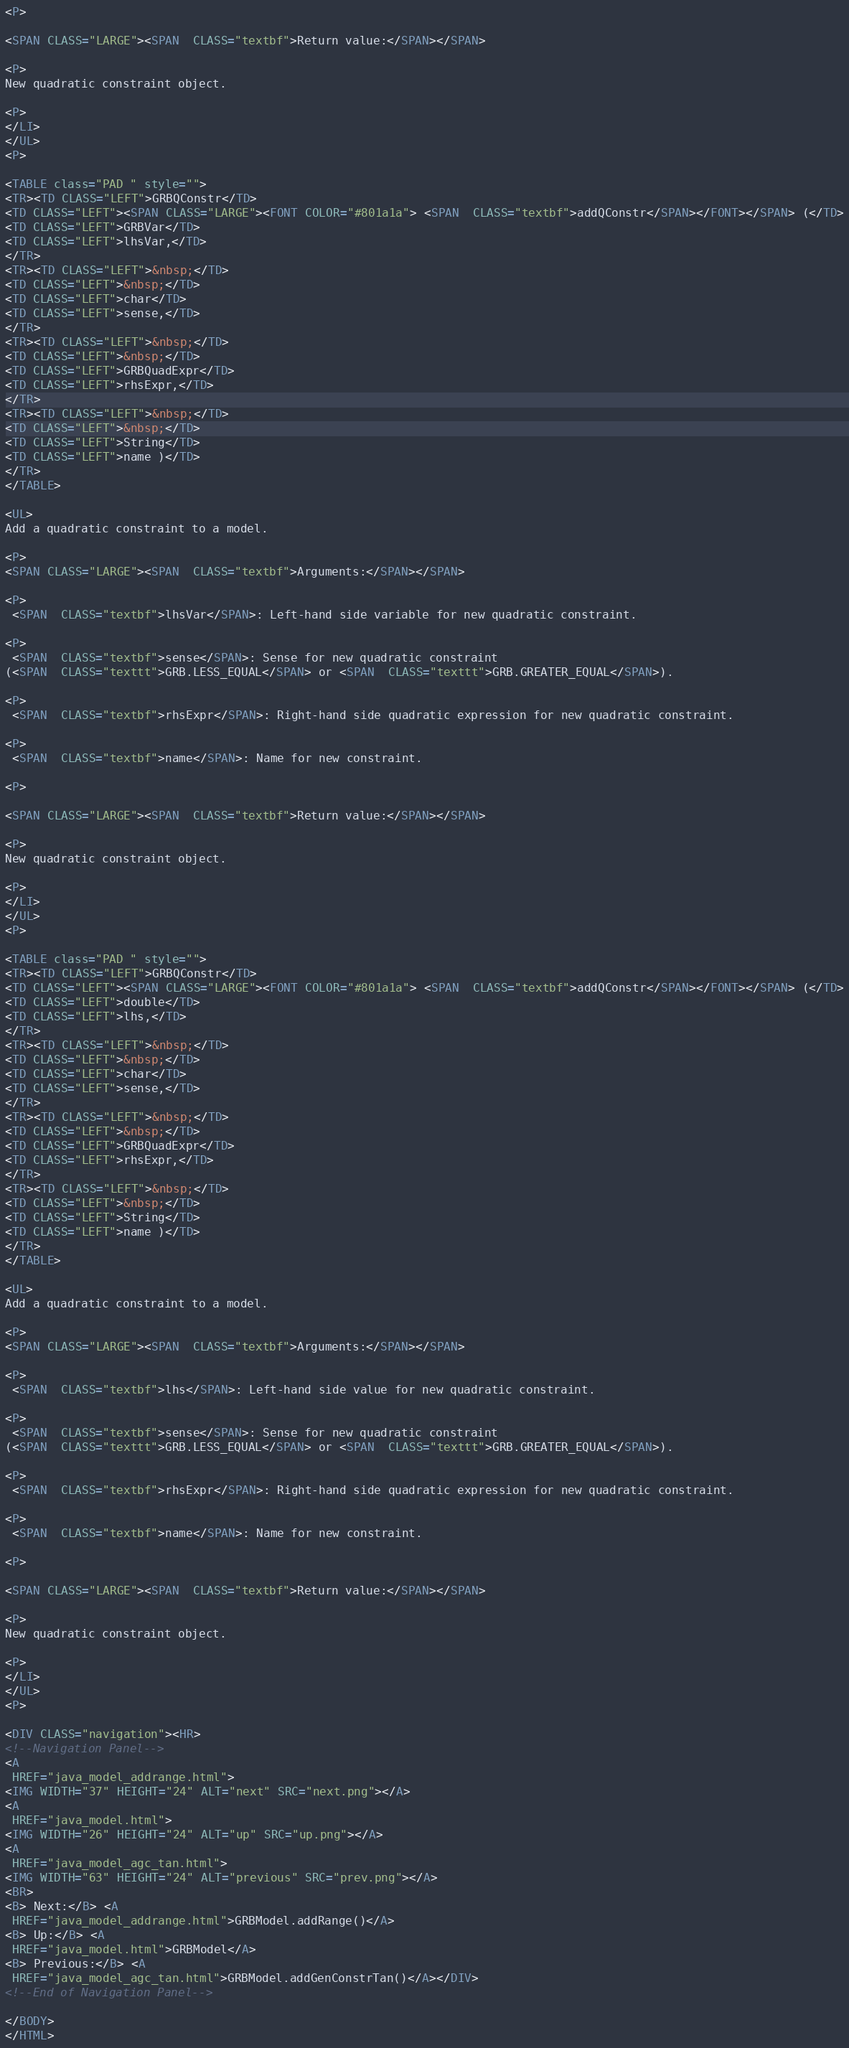Convert code to text. <code><loc_0><loc_0><loc_500><loc_500><_HTML_>
<P>

<SPAN CLASS="LARGE"><SPAN  CLASS="textbf">Return value:</SPAN></SPAN>

<P>
New quadratic constraint object.

<P>
</LI>
</UL>
<P>

<TABLE class="PAD " style="">
<TR><TD CLASS="LEFT">GRBQConstr</TD>
<TD CLASS="LEFT"><SPAN CLASS="LARGE"><FONT COLOR="#801a1a"> <SPAN  CLASS="textbf">addQConstr</SPAN></FONT></SPAN> (</TD>
<TD CLASS="LEFT">GRBVar</TD>
<TD CLASS="LEFT">lhsVar,</TD>
</TR>
<TR><TD CLASS="LEFT">&nbsp;</TD>
<TD CLASS="LEFT">&nbsp;</TD>
<TD CLASS="LEFT">char</TD>
<TD CLASS="LEFT">sense,</TD>
</TR>
<TR><TD CLASS="LEFT">&nbsp;</TD>
<TD CLASS="LEFT">&nbsp;</TD>
<TD CLASS="LEFT">GRBQuadExpr</TD>
<TD CLASS="LEFT">rhsExpr,</TD>
</TR>
<TR><TD CLASS="LEFT">&nbsp;</TD>
<TD CLASS="LEFT">&nbsp;</TD>
<TD CLASS="LEFT">String</TD>
<TD CLASS="LEFT">name )</TD>
</TR>
</TABLE>

<UL>
Add a quadratic constraint to a model.

<P>
<SPAN CLASS="LARGE"><SPAN  CLASS="textbf">Arguments:</SPAN></SPAN>

<P>
 <SPAN  CLASS="textbf">lhsVar</SPAN>: Left-hand side variable for new quadratic constraint.

<P>
 <SPAN  CLASS="textbf">sense</SPAN>: Sense for new quadratic constraint
(<SPAN  CLASS="texttt">GRB.LESS_EQUAL</SPAN> or <SPAN  CLASS="texttt">GRB.GREATER_EQUAL</SPAN>).

<P>
 <SPAN  CLASS="textbf">rhsExpr</SPAN>: Right-hand side quadratic expression for new quadratic constraint.

<P>
 <SPAN  CLASS="textbf">name</SPAN>: Name for new constraint.

<P>

<SPAN CLASS="LARGE"><SPAN  CLASS="textbf">Return value:</SPAN></SPAN>

<P>
New quadratic constraint object.

<P>
</LI>
</UL>
<P>

<TABLE class="PAD " style="">
<TR><TD CLASS="LEFT">GRBQConstr</TD>
<TD CLASS="LEFT"><SPAN CLASS="LARGE"><FONT COLOR="#801a1a"> <SPAN  CLASS="textbf">addQConstr</SPAN></FONT></SPAN> (</TD>
<TD CLASS="LEFT">double</TD>
<TD CLASS="LEFT">lhs,</TD>
</TR>
<TR><TD CLASS="LEFT">&nbsp;</TD>
<TD CLASS="LEFT">&nbsp;</TD>
<TD CLASS="LEFT">char</TD>
<TD CLASS="LEFT">sense,</TD>
</TR>
<TR><TD CLASS="LEFT">&nbsp;</TD>
<TD CLASS="LEFT">&nbsp;</TD>
<TD CLASS="LEFT">GRBQuadExpr</TD>
<TD CLASS="LEFT">rhsExpr,</TD>
</TR>
<TR><TD CLASS="LEFT">&nbsp;</TD>
<TD CLASS="LEFT">&nbsp;</TD>
<TD CLASS="LEFT">String</TD>
<TD CLASS="LEFT">name )</TD>
</TR>
</TABLE>

<UL>
Add a quadratic constraint to a model.

<P>
<SPAN CLASS="LARGE"><SPAN  CLASS="textbf">Arguments:</SPAN></SPAN>

<P>
 <SPAN  CLASS="textbf">lhs</SPAN>: Left-hand side value for new quadratic constraint.

<P>
 <SPAN  CLASS="textbf">sense</SPAN>: Sense for new quadratic constraint
(<SPAN  CLASS="texttt">GRB.LESS_EQUAL</SPAN> or <SPAN  CLASS="texttt">GRB.GREATER_EQUAL</SPAN>).

<P>
 <SPAN  CLASS="textbf">rhsExpr</SPAN>: Right-hand side quadratic expression for new quadratic constraint.

<P>
 <SPAN  CLASS="textbf">name</SPAN>: Name for new constraint.

<P>

<SPAN CLASS="LARGE"><SPAN  CLASS="textbf">Return value:</SPAN></SPAN>

<P>
New quadratic constraint object.

<P>
</LI>
</UL>
<P>

<DIV CLASS="navigation"><HR>
<!--Navigation Panel-->
<A
 HREF="java_model_addrange.html">
<IMG WIDTH="37" HEIGHT="24" ALT="next" SRC="next.png"></A> 
<A
 HREF="java_model.html">
<IMG WIDTH="26" HEIGHT="24" ALT="up" SRC="up.png"></A> 
<A
 HREF="java_model_agc_tan.html">
<IMG WIDTH="63" HEIGHT="24" ALT="previous" SRC="prev.png"></A>   
<BR>
<B> Next:</B> <A
 HREF="java_model_addrange.html">GRBModel.addRange()</A>
<B> Up:</B> <A
 HREF="java_model.html">GRBModel</A>
<B> Previous:</B> <A
 HREF="java_model_agc_tan.html">GRBModel.addGenConstrTan()</A></DIV>
<!--End of Navigation Panel-->

</BODY>
</HTML>
</code> 